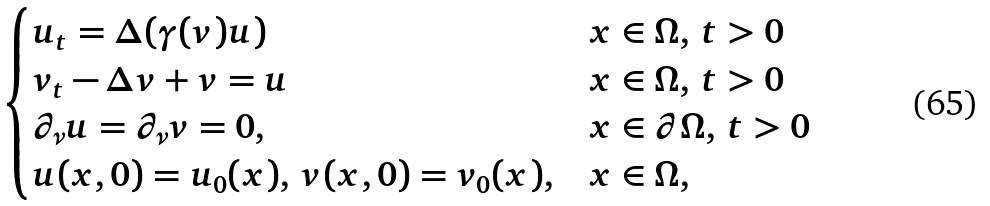<formula> <loc_0><loc_0><loc_500><loc_500>\begin{cases} u _ { t } = \Delta ( \gamma ( v ) u ) & x \in \Omega , \, t > 0 \\ v _ { t } - \Delta v + v = u & x \in \Omega , \, t > 0 \\ \partial _ { \nu } u = \partial _ { \nu } v = 0 , & x \in \partial \Omega , \, t > 0 \\ u ( x , 0 ) = u _ { 0 } ( x ) , \, v ( x , 0 ) = v _ { 0 } ( x ) , & x \in \Omega , \end{cases}</formula> 